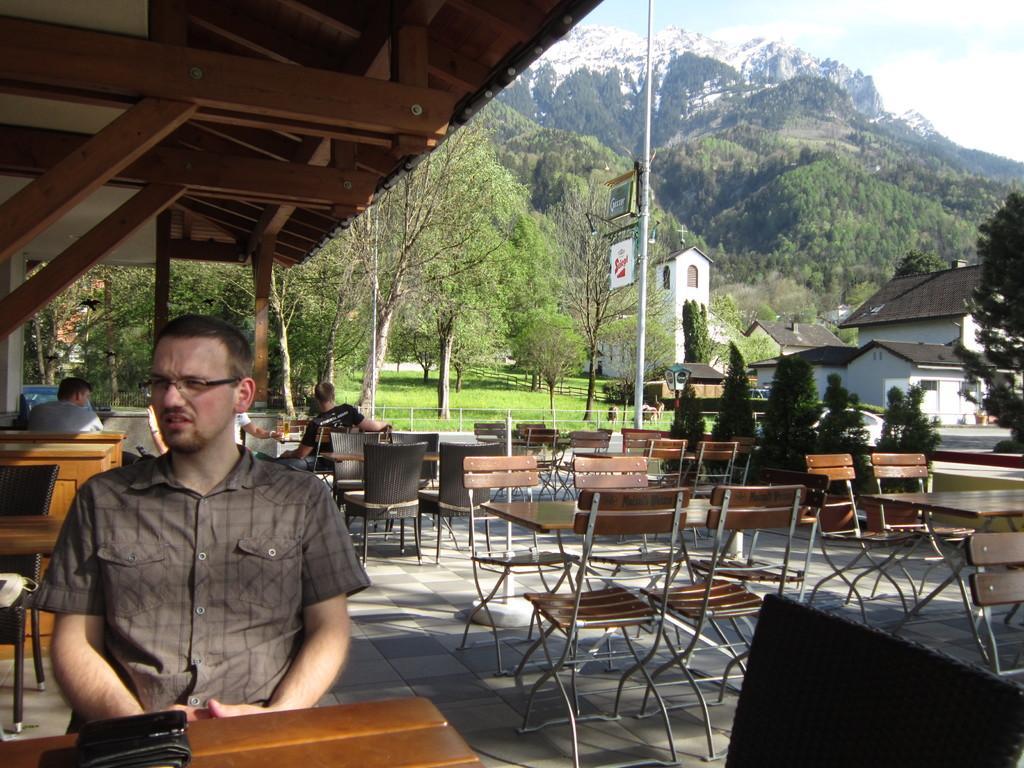Could you give a brief overview of what you see in this image? This is the picture of the outside of the hotel. He is sitting in a chair. There is a purse on a table. We can see in the background there is a tree,sky,mountain,name poster and houses. 